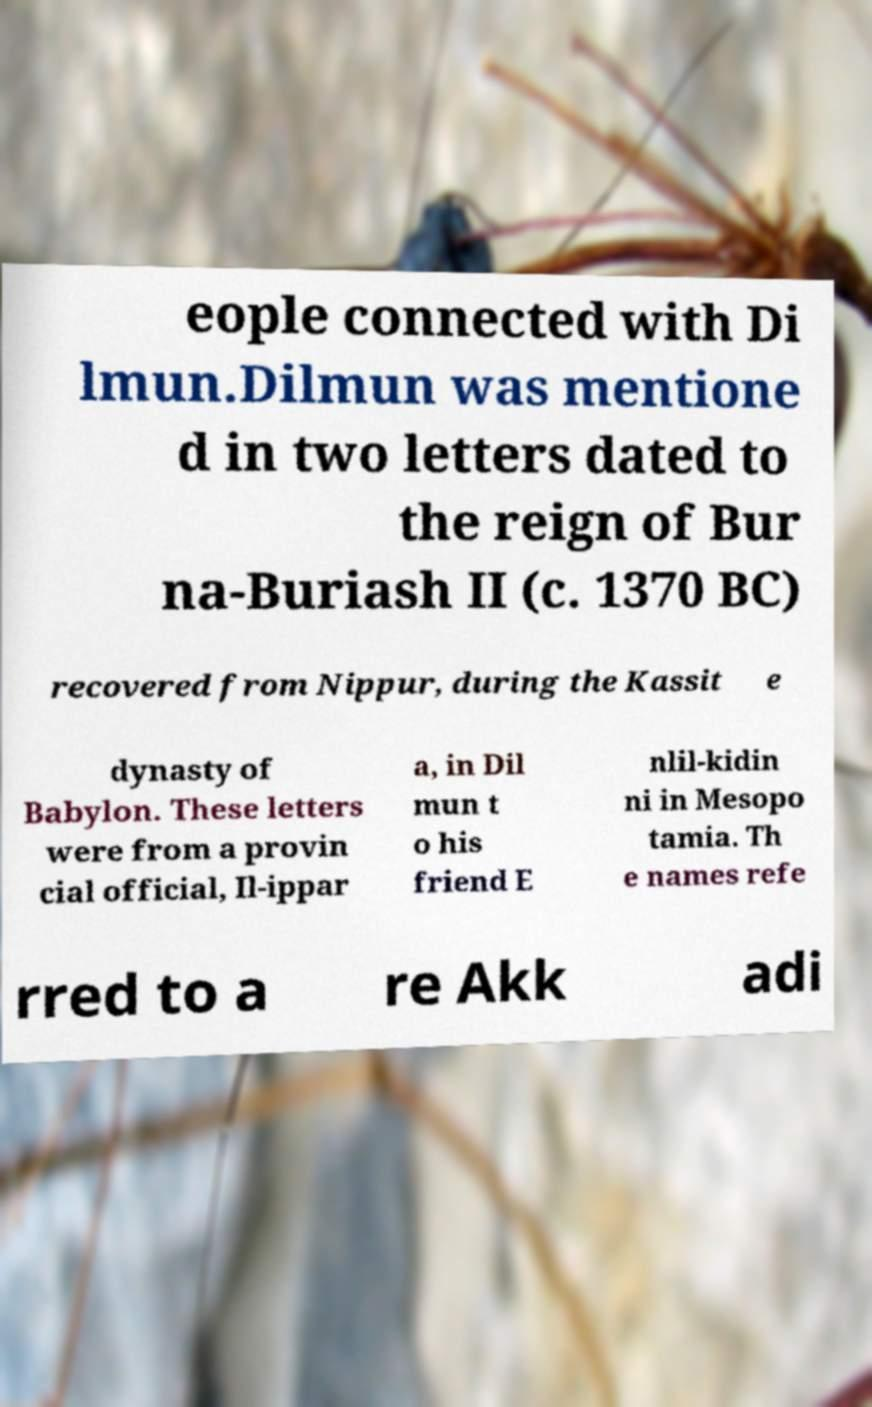Please read and relay the text visible in this image. What does it say? eople connected with Di lmun.Dilmun was mentione d in two letters dated to the reign of Bur na-Buriash II (c. 1370 BC) recovered from Nippur, during the Kassit e dynasty of Babylon. These letters were from a provin cial official, Il-ippar a, in Dil mun t o his friend E nlil-kidin ni in Mesopo tamia. Th e names refe rred to a re Akk adi 